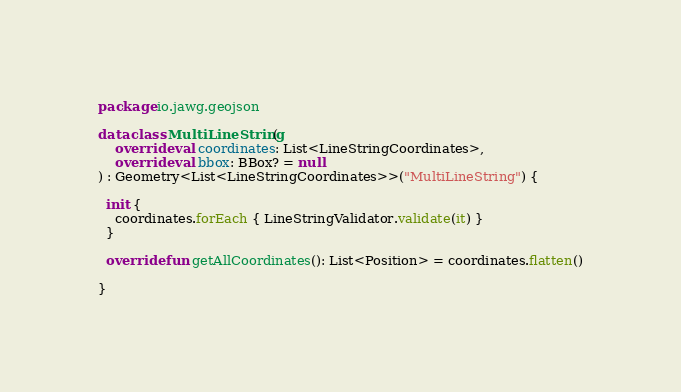<code> <loc_0><loc_0><loc_500><loc_500><_Kotlin_>package io.jawg.geojson

data class MultiLineString(
    override val coordinates: List<LineStringCoordinates>,
    override val bbox: BBox? = null
) : Geometry<List<LineStringCoordinates>>("MultiLineString") {

  init {
    coordinates.forEach { LineStringValidator.validate(it) }
  }

  override fun getAllCoordinates(): List<Position> = coordinates.flatten()

}
</code> 